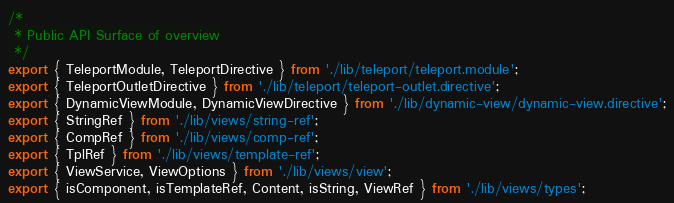<code> <loc_0><loc_0><loc_500><loc_500><_TypeScript_>/*
 * Public API Surface of overview
 */
export { TeleportModule, TeleportDirective } from './lib/teleport/teleport.module';
export { TeleportOutletDirective } from './lib/teleport/teleport-outlet.directive';
export { DynamicViewModule, DynamicViewDirective } from './lib/dynamic-view/dynamic-view.directive';
export { StringRef } from './lib/views/string-ref';
export { CompRef } from './lib/views/comp-ref';
export { TplRef } from './lib/views/template-ref';
export { ViewService, ViewOptions } from './lib/views/view';
export { isComponent, isTemplateRef, Content, isString, ViewRef } from './lib/views/types';
</code> 